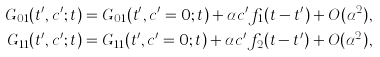<formula> <loc_0><loc_0><loc_500><loc_500>G _ { 0 1 } ( t ^ { \prime } , c ^ { \prime } ; t ) & = G _ { 0 1 } ( t ^ { \prime } , c ^ { \prime } = 0 ; t ) + \alpha c ^ { \prime } f _ { 1 } ( t - t ^ { \prime } ) + O ( \alpha ^ { 2 } ) , \\ G _ { 1 1 } ( t ^ { \prime } , c ^ { \prime } ; t ) & = G _ { 1 1 } ( t ^ { \prime } , c ^ { \prime } = 0 ; t ) + \alpha c ^ { \prime } f _ { 2 } ( t - t ^ { \prime } ) + O ( \alpha ^ { 2 } ) ,</formula> 